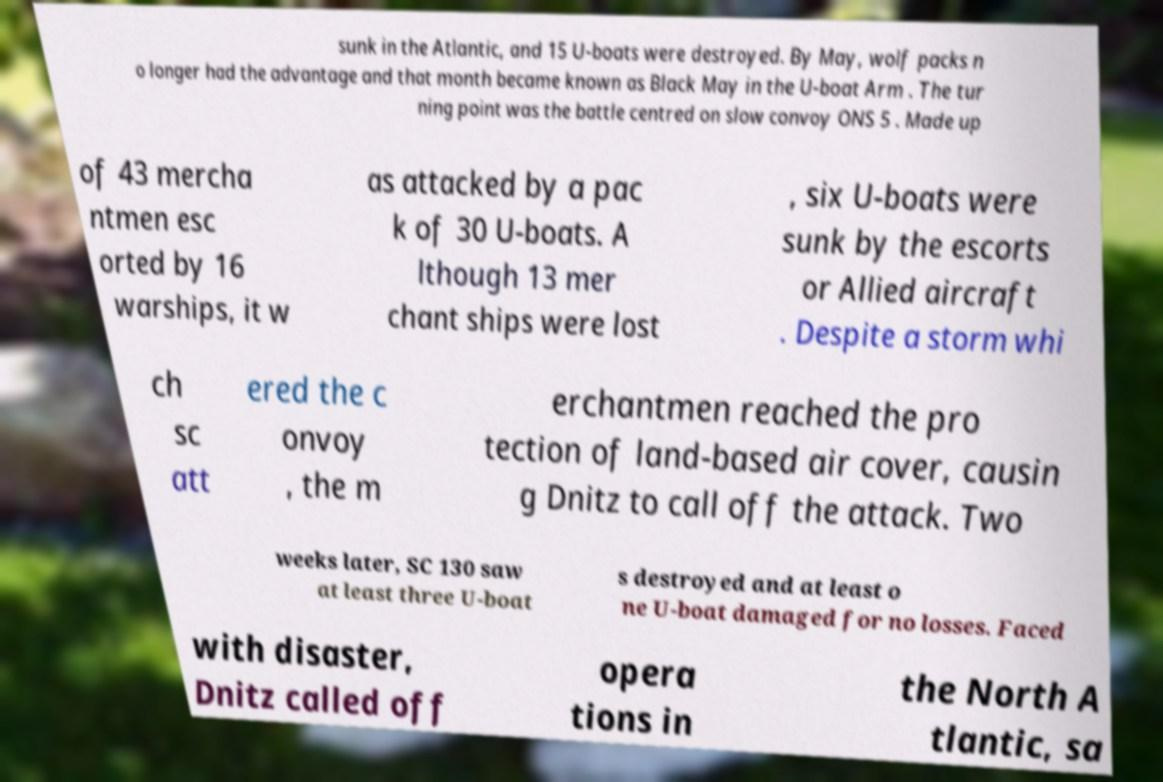Please identify and transcribe the text found in this image. sunk in the Atlantic, and 15 U-boats were destroyed. By May, wolf packs n o longer had the advantage and that month became known as Black May in the U-boat Arm . The tur ning point was the battle centred on slow convoy ONS 5 . Made up of 43 mercha ntmen esc orted by 16 warships, it w as attacked by a pac k of 30 U-boats. A lthough 13 mer chant ships were lost , six U-boats were sunk by the escorts or Allied aircraft . Despite a storm whi ch sc att ered the c onvoy , the m erchantmen reached the pro tection of land-based air cover, causin g Dnitz to call off the attack. Two weeks later, SC 130 saw at least three U-boat s destroyed and at least o ne U-boat damaged for no losses. Faced with disaster, Dnitz called off opera tions in the North A tlantic, sa 